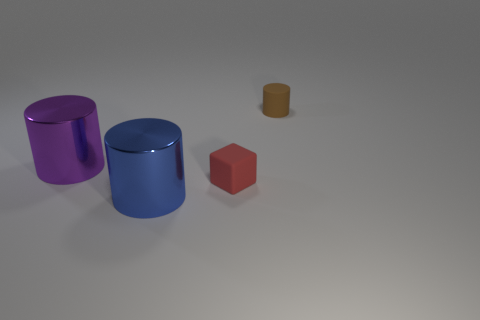What number of objects are the same size as the brown cylinder?
Offer a terse response. 1. Does the rubber object that is on the left side of the rubber cylinder have the same size as the blue metallic thing?
Provide a short and direct response. No. The red object is what shape?
Keep it short and to the point. Cube. Are the tiny thing on the left side of the tiny brown rubber thing and the brown object made of the same material?
Provide a short and direct response. Yes. There is a big metallic object behind the blue metallic thing; does it have the same shape as the small rubber object on the right side of the tiny red matte cube?
Give a very brief answer. Yes. Are there any objects that have the same material as the red cube?
Your answer should be very brief. Yes. What number of purple objects are either things or metallic cylinders?
Your answer should be compact. 1. There is a object that is to the left of the red matte block and in front of the purple metal thing; what is its size?
Make the answer very short. Large. Are there more big objects that are in front of the purple metal object than tiny gray things?
Offer a very short reply. Yes. What number of cubes are either tiny rubber objects or big metal objects?
Offer a very short reply. 1. 